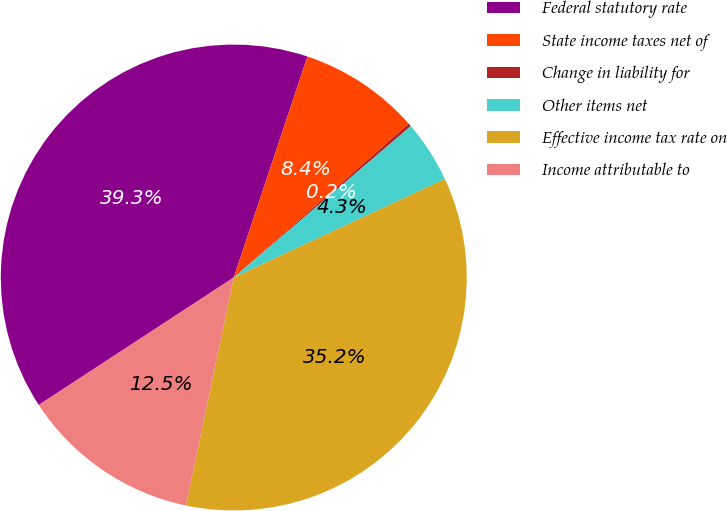<chart> <loc_0><loc_0><loc_500><loc_500><pie_chart><fcel>Federal statutory rate<fcel>State income taxes net of<fcel>Change in liability for<fcel>Other items net<fcel>Effective income tax rate on<fcel>Income attributable to<nl><fcel>39.34%<fcel>8.4%<fcel>0.22%<fcel>4.31%<fcel>35.25%<fcel>12.49%<nl></chart> 